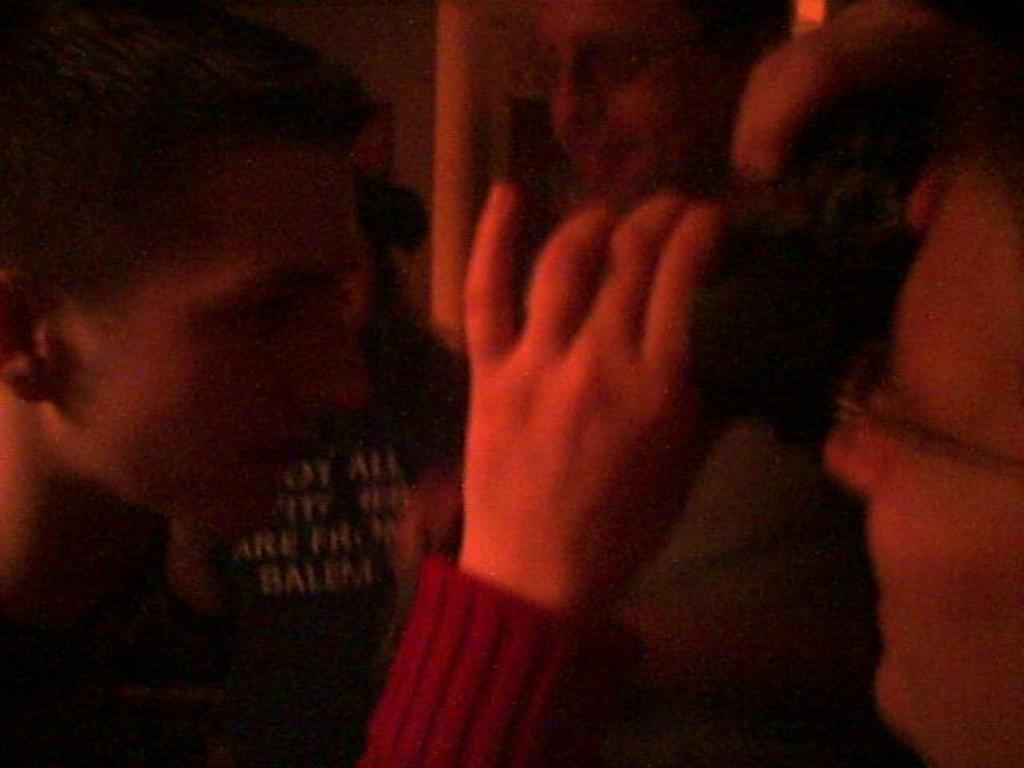Please provide a concise description of this image. In this image we can see a group of persons. In the background, we can see the text on a person's shirt. 